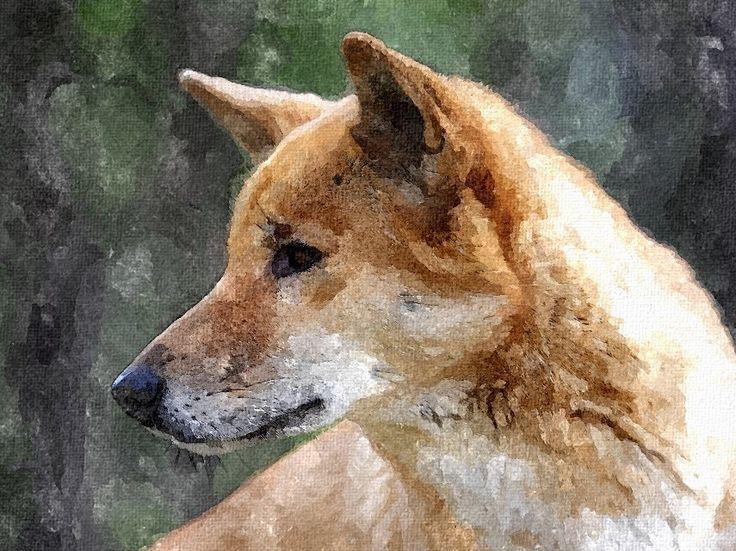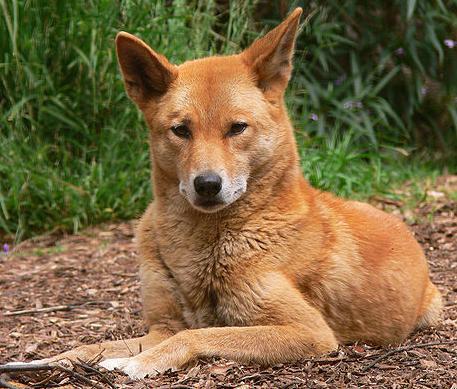The first image is the image on the left, the second image is the image on the right. For the images displayed, is the sentence "At least one of the dogs is in front of a large body of water." factually correct? Answer yes or no. No. The first image is the image on the left, the second image is the image on the right. Analyze the images presented: Is the assertion "In at least one of the images, there is a large body of water in the background." valid? Answer yes or no. No. 